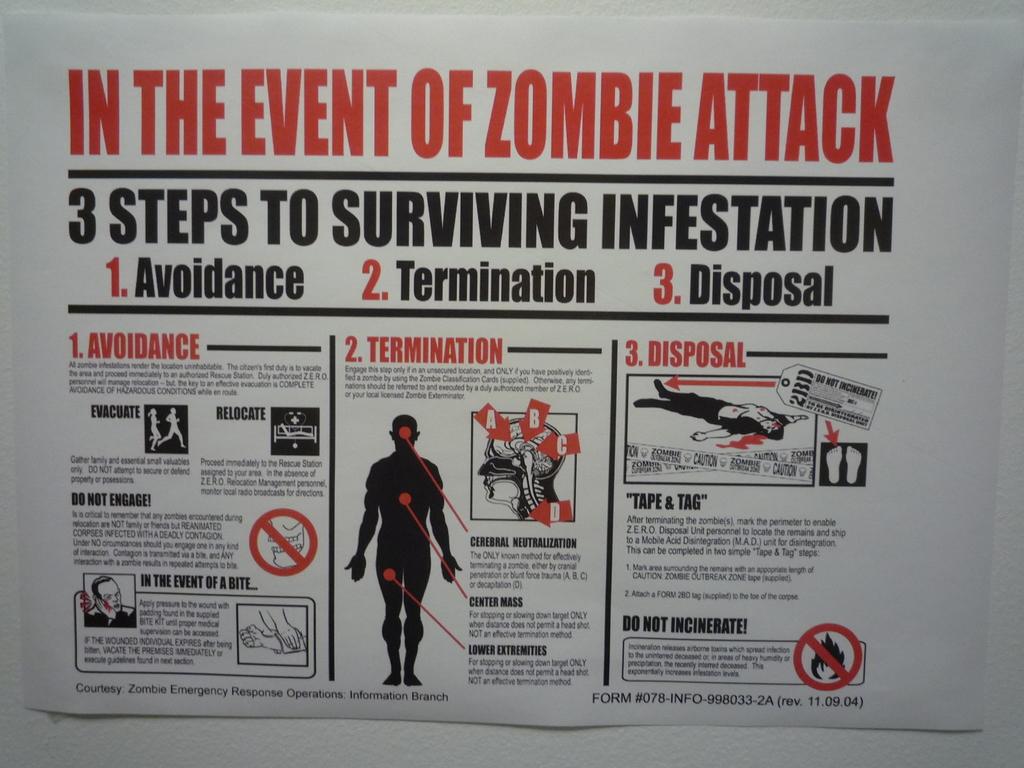In the event of what kind of attack?
Ensure brevity in your answer.  Zombie. How many steps are there to survive infestation?
Ensure brevity in your answer.  3. 